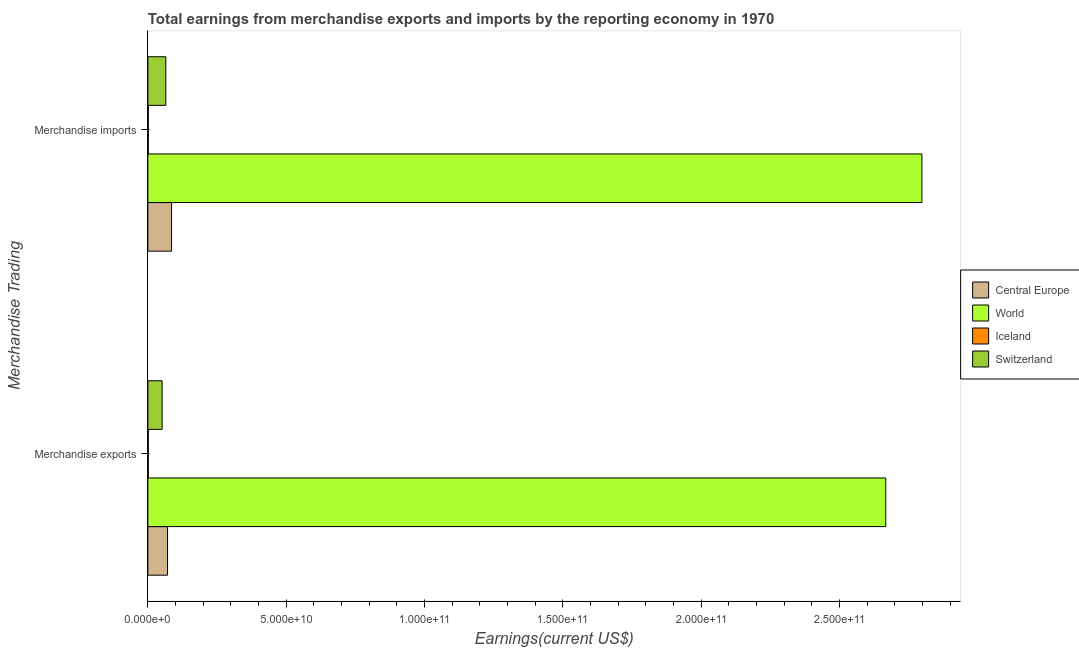Are the number of bars per tick equal to the number of legend labels?
Your answer should be compact. Yes. How many bars are there on the 1st tick from the bottom?
Provide a succinct answer. 4. What is the label of the 2nd group of bars from the top?
Ensure brevity in your answer.  Merchandise exports. What is the earnings from merchandise imports in Iceland?
Your answer should be very brief. 1.57e+08. Across all countries, what is the maximum earnings from merchandise imports?
Ensure brevity in your answer.  2.80e+11. Across all countries, what is the minimum earnings from merchandise exports?
Keep it short and to the point. 1.47e+08. In which country was the earnings from merchandise exports maximum?
Offer a terse response. World. What is the total earnings from merchandise exports in the graph?
Your answer should be very brief. 2.79e+11. What is the difference between the earnings from merchandise imports in World and that in Switzerland?
Your response must be concise. 2.73e+11. What is the difference between the earnings from merchandise imports in Iceland and the earnings from merchandise exports in Central Europe?
Give a very brief answer. -6.96e+09. What is the average earnings from merchandise imports per country?
Your answer should be very brief. 7.38e+1. What is the difference between the earnings from merchandise imports and earnings from merchandise exports in Central Europe?
Provide a succinct answer. 1.45e+09. What is the ratio of the earnings from merchandise imports in Central Europe to that in World?
Provide a succinct answer. 0.03. In how many countries, is the earnings from merchandise imports greater than the average earnings from merchandise imports taken over all countries?
Your answer should be compact. 1. What does the 3rd bar from the top in Merchandise exports represents?
Make the answer very short. World. What does the 2nd bar from the bottom in Merchandise imports represents?
Keep it short and to the point. World. Are all the bars in the graph horizontal?
Your answer should be very brief. Yes. How many countries are there in the graph?
Provide a short and direct response. 4. What is the difference between two consecutive major ticks on the X-axis?
Provide a succinct answer. 5.00e+1. Are the values on the major ticks of X-axis written in scientific E-notation?
Provide a short and direct response. Yes. Where does the legend appear in the graph?
Offer a terse response. Center right. How many legend labels are there?
Make the answer very short. 4. What is the title of the graph?
Your response must be concise. Total earnings from merchandise exports and imports by the reporting economy in 1970. What is the label or title of the X-axis?
Provide a short and direct response. Earnings(current US$). What is the label or title of the Y-axis?
Make the answer very short. Merchandise Trading. What is the Earnings(current US$) of Central Europe in Merchandise exports?
Keep it short and to the point. 7.12e+09. What is the Earnings(current US$) of World in Merchandise exports?
Your answer should be compact. 2.67e+11. What is the Earnings(current US$) of Iceland in Merchandise exports?
Keep it short and to the point. 1.47e+08. What is the Earnings(current US$) of Switzerland in Merchandise exports?
Make the answer very short. 5.16e+09. What is the Earnings(current US$) in Central Europe in Merchandise imports?
Make the answer very short. 8.57e+09. What is the Earnings(current US$) of World in Merchandise imports?
Make the answer very short. 2.80e+11. What is the Earnings(current US$) in Iceland in Merchandise imports?
Make the answer very short. 1.57e+08. What is the Earnings(current US$) in Switzerland in Merchandise imports?
Your response must be concise. 6.49e+09. Across all Merchandise Trading, what is the maximum Earnings(current US$) in Central Europe?
Make the answer very short. 8.57e+09. Across all Merchandise Trading, what is the maximum Earnings(current US$) of World?
Provide a short and direct response. 2.80e+11. Across all Merchandise Trading, what is the maximum Earnings(current US$) in Iceland?
Provide a short and direct response. 1.57e+08. Across all Merchandise Trading, what is the maximum Earnings(current US$) of Switzerland?
Offer a terse response. 6.49e+09. Across all Merchandise Trading, what is the minimum Earnings(current US$) in Central Europe?
Your response must be concise. 7.12e+09. Across all Merchandise Trading, what is the minimum Earnings(current US$) of World?
Provide a succinct answer. 2.67e+11. Across all Merchandise Trading, what is the minimum Earnings(current US$) in Iceland?
Keep it short and to the point. 1.47e+08. Across all Merchandise Trading, what is the minimum Earnings(current US$) of Switzerland?
Make the answer very short. 5.16e+09. What is the total Earnings(current US$) in Central Europe in the graph?
Ensure brevity in your answer.  1.57e+1. What is the total Earnings(current US$) in World in the graph?
Your answer should be very brief. 5.47e+11. What is the total Earnings(current US$) of Iceland in the graph?
Provide a succinct answer. 3.04e+08. What is the total Earnings(current US$) of Switzerland in the graph?
Provide a short and direct response. 1.16e+1. What is the difference between the Earnings(current US$) of Central Europe in Merchandise exports and that in Merchandise imports?
Offer a very short reply. -1.45e+09. What is the difference between the Earnings(current US$) in World in Merchandise exports and that in Merchandise imports?
Keep it short and to the point. -1.31e+1. What is the difference between the Earnings(current US$) of Iceland in Merchandise exports and that in Merchandise imports?
Offer a terse response. -1.01e+07. What is the difference between the Earnings(current US$) in Switzerland in Merchandise exports and that in Merchandise imports?
Give a very brief answer. -1.33e+09. What is the difference between the Earnings(current US$) of Central Europe in Merchandise exports and the Earnings(current US$) of World in Merchandise imports?
Give a very brief answer. -2.73e+11. What is the difference between the Earnings(current US$) in Central Europe in Merchandise exports and the Earnings(current US$) in Iceland in Merchandise imports?
Offer a terse response. 6.96e+09. What is the difference between the Earnings(current US$) of Central Europe in Merchandise exports and the Earnings(current US$) of Switzerland in Merchandise imports?
Give a very brief answer. 6.28e+08. What is the difference between the Earnings(current US$) in World in Merchandise exports and the Earnings(current US$) in Iceland in Merchandise imports?
Make the answer very short. 2.67e+11. What is the difference between the Earnings(current US$) of World in Merchandise exports and the Earnings(current US$) of Switzerland in Merchandise imports?
Provide a succinct answer. 2.60e+11. What is the difference between the Earnings(current US$) of Iceland in Merchandise exports and the Earnings(current US$) of Switzerland in Merchandise imports?
Give a very brief answer. -6.34e+09. What is the average Earnings(current US$) of Central Europe per Merchandise Trading?
Provide a succinct answer. 7.84e+09. What is the average Earnings(current US$) of World per Merchandise Trading?
Your answer should be very brief. 2.73e+11. What is the average Earnings(current US$) in Iceland per Merchandise Trading?
Make the answer very short. 1.52e+08. What is the average Earnings(current US$) in Switzerland per Merchandise Trading?
Your answer should be very brief. 5.82e+09. What is the difference between the Earnings(current US$) in Central Europe and Earnings(current US$) in World in Merchandise exports?
Your response must be concise. -2.60e+11. What is the difference between the Earnings(current US$) of Central Europe and Earnings(current US$) of Iceland in Merchandise exports?
Offer a very short reply. 6.97e+09. What is the difference between the Earnings(current US$) of Central Europe and Earnings(current US$) of Switzerland in Merchandise exports?
Keep it short and to the point. 1.96e+09. What is the difference between the Earnings(current US$) of World and Earnings(current US$) of Iceland in Merchandise exports?
Your answer should be very brief. 2.67e+11. What is the difference between the Earnings(current US$) of World and Earnings(current US$) of Switzerland in Merchandise exports?
Your answer should be very brief. 2.62e+11. What is the difference between the Earnings(current US$) in Iceland and Earnings(current US$) in Switzerland in Merchandise exports?
Keep it short and to the point. -5.01e+09. What is the difference between the Earnings(current US$) of Central Europe and Earnings(current US$) of World in Merchandise imports?
Offer a very short reply. -2.71e+11. What is the difference between the Earnings(current US$) of Central Europe and Earnings(current US$) of Iceland in Merchandise imports?
Provide a short and direct response. 8.41e+09. What is the difference between the Earnings(current US$) of Central Europe and Earnings(current US$) of Switzerland in Merchandise imports?
Keep it short and to the point. 2.08e+09. What is the difference between the Earnings(current US$) of World and Earnings(current US$) of Iceland in Merchandise imports?
Your answer should be very brief. 2.80e+11. What is the difference between the Earnings(current US$) of World and Earnings(current US$) of Switzerland in Merchandise imports?
Your answer should be very brief. 2.73e+11. What is the difference between the Earnings(current US$) in Iceland and Earnings(current US$) in Switzerland in Merchandise imports?
Your answer should be very brief. -6.33e+09. What is the ratio of the Earnings(current US$) in Central Europe in Merchandise exports to that in Merchandise imports?
Your answer should be compact. 0.83. What is the ratio of the Earnings(current US$) in World in Merchandise exports to that in Merchandise imports?
Offer a terse response. 0.95. What is the ratio of the Earnings(current US$) in Iceland in Merchandise exports to that in Merchandise imports?
Your answer should be very brief. 0.94. What is the ratio of the Earnings(current US$) in Switzerland in Merchandise exports to that in Merchandise imports?
Offer a very short reply. 0.79. What is the difference between the highest and the second highest Earnings(current US$) in Central Europe?
Keep it short and to the point. 1.45e+09. What is the difference between the highest and the second highest Earnings(current US$) in World?
Your answer should be very brief. 1.31e+1. What is the difference between the highest and the second highest Earnings(current US$) in Iceland?
Your response must be concise. 1.01e+07. What is the difference between the highest and the second highest Earnings(current US$) of Switzerland?
Offer a very short reply. 1.33e+09. What is the difference between the highest and the lowest Earnings(current US$) in Central Europe?
Your answer should be compact. 1.45e+09. What is the difference between the highest and the lowest Earnings(current US$) of World?
Your answer should be very brief. 1.31e+1. What is the difference between the highest and the lowest Earnings(current US$) of Iceland?
Give a very brief answer. 1.01e+07. What is the difference between the highest and the lowest Earnings(current US$) in Switzerland?
Ensure brevity in your answer.  1.33e+09. 